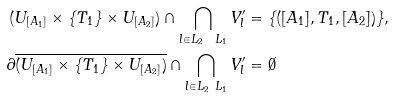Convert formula to latex. <formula><loc_0><loc_0><loc_500><loc_500>( U _ { [ A _ { 1 } ] } \times \{ T _ { 1 } \} \times U _ { [ A _ { 2 } ] } ) \cap \bigcap _ { l \in L _ { 2 } \ L _ { 1 } } V _ { l } ^ { \prime } & = \{ ( [ A _ { 1 } ] , T _ { 1 } , [ A _ { 2 } ] ) \} , \\ \partial \overline { ( U _ { [ A _ { 1 } ] } \times \{ T _ { 1 } \} \times U _ { [ A _ { 2 } ] } ) } \cap \bigcap _ { l \in L _ { 2 } \ L _ { 1 } } V _ { l } ^ { \prime } & = \emptyset</formula> 